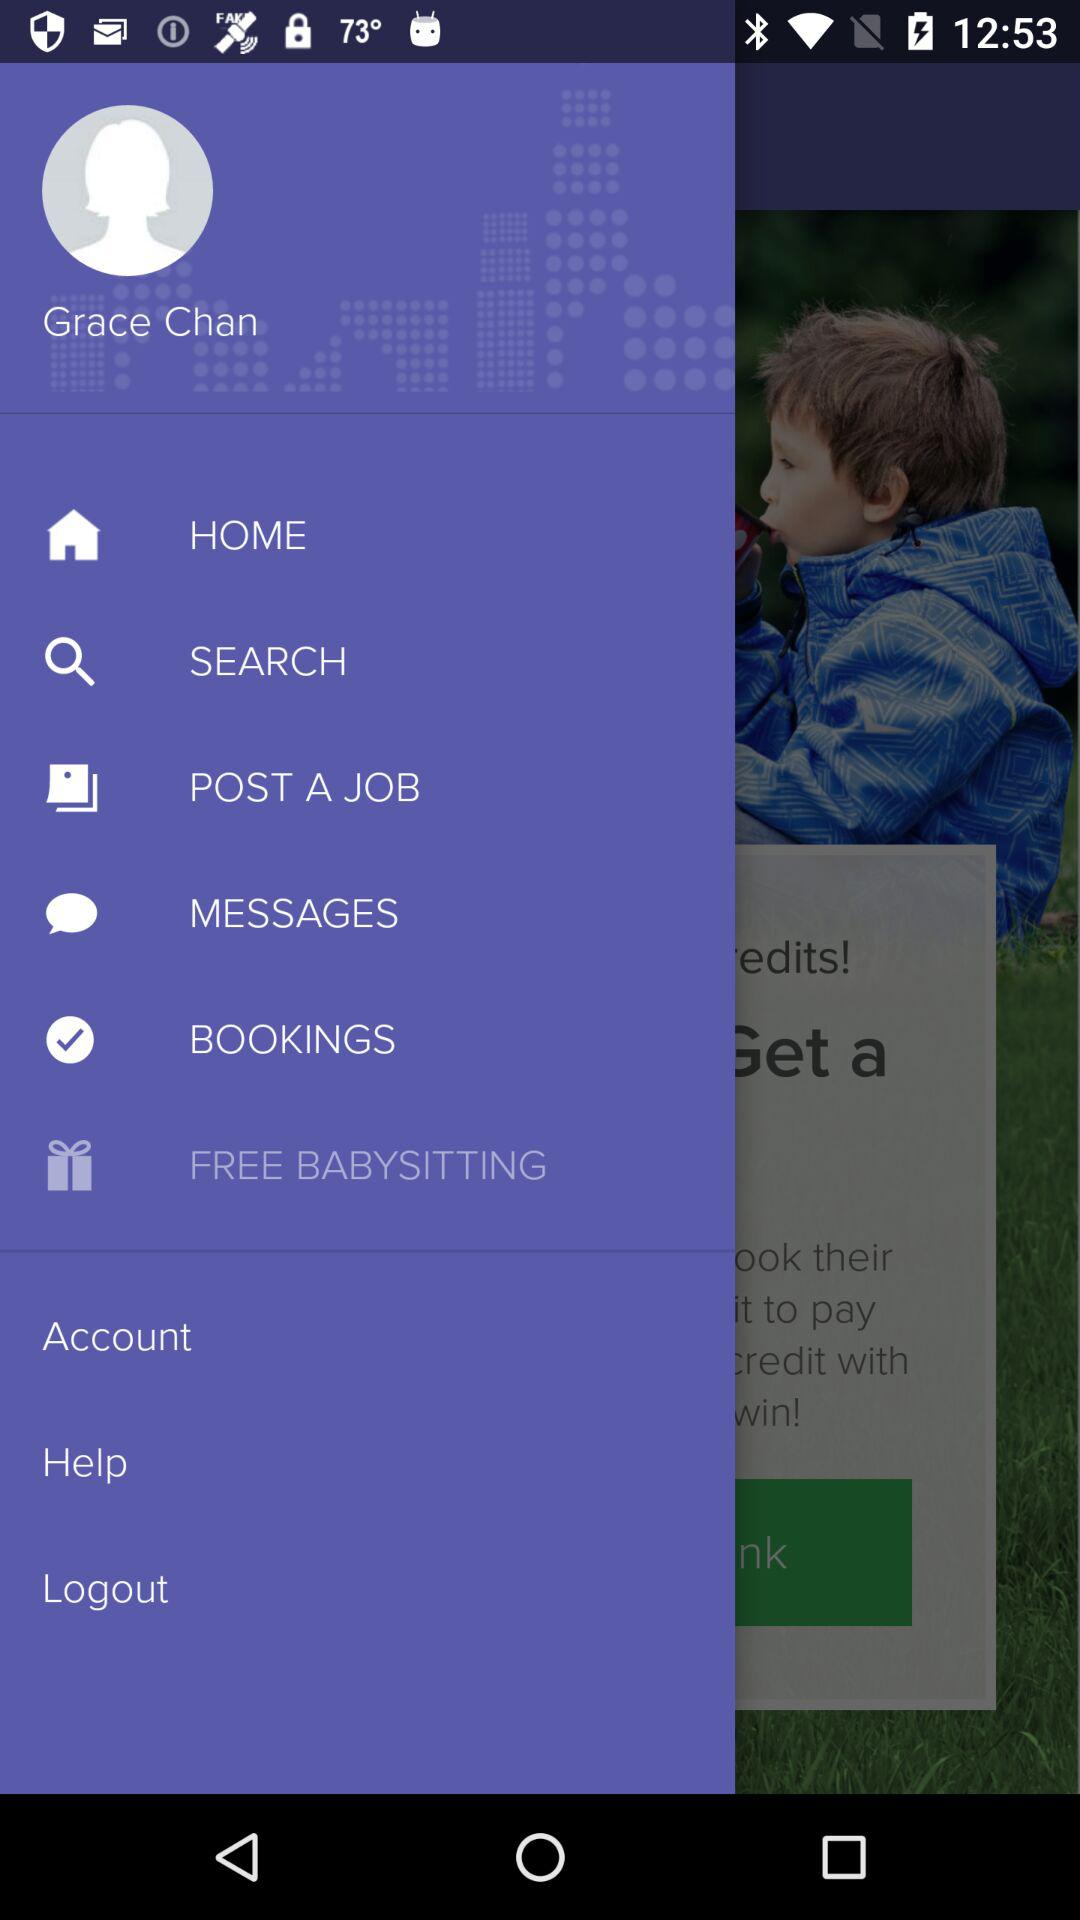What is the user profile name? The user profile name is Grace Chan. 